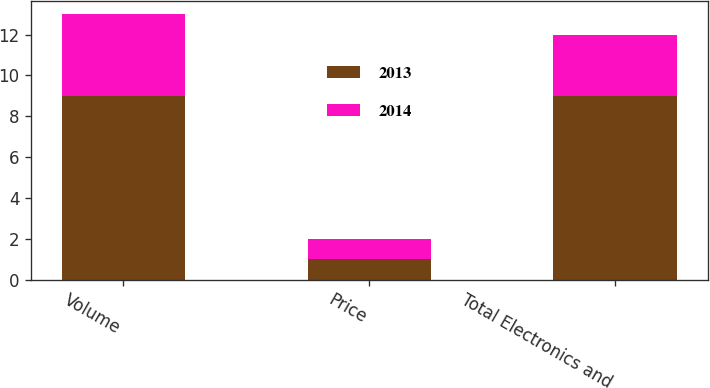<chart> <loc_0><loc_0><loc_500><loc_500><stacked_bar_chart><ecel><fcel>Volume<fcel>Price<fcel>Total Electronics and<nl><fcel>2013<fcel>9<fcel>1<fcel>9<nl><fcel>2014<fcel>4<fcel>1<fcel>3<nl></chart> 